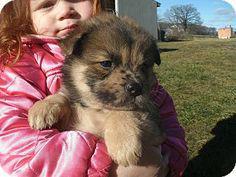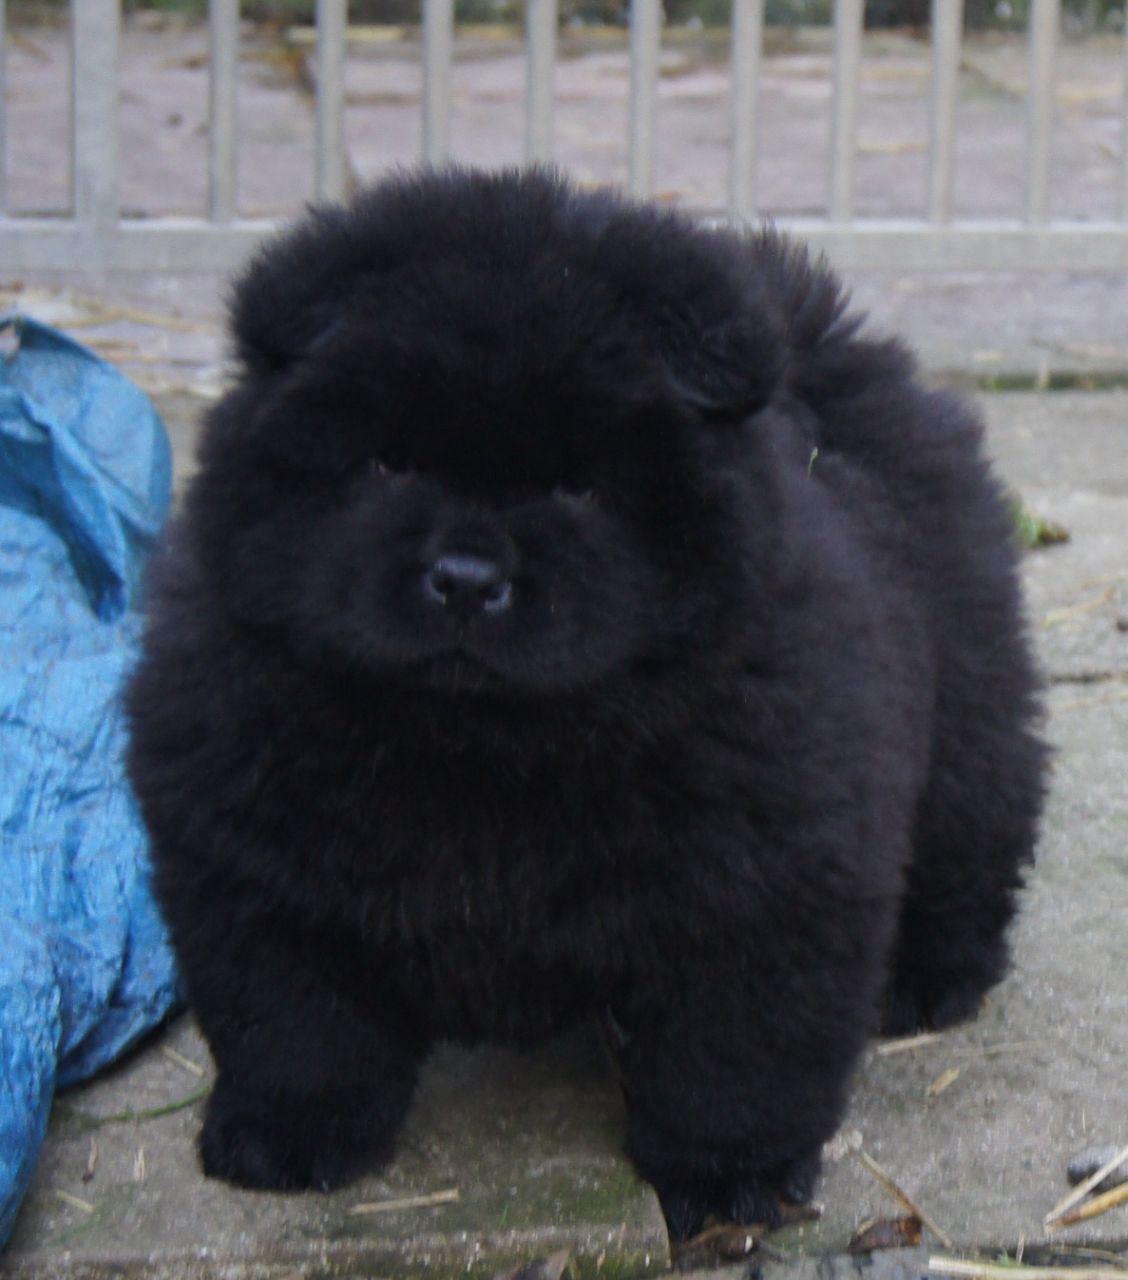The first image is the image on the left, the second image is the image on the right. Assess this claim about the two images: "A person holds up a chow puppy in the left image, and the right image features a black chow puppy in front of a metal fence-like barrier.". Correct or not? Answer yes or no. Yes. The first image is the image on the left, the second image is the image on the right. Considering the images on both sides, is "One image in the pair shows a single black dog and the other shows a single tan dog." valid? Answer yes or no. Yes. 